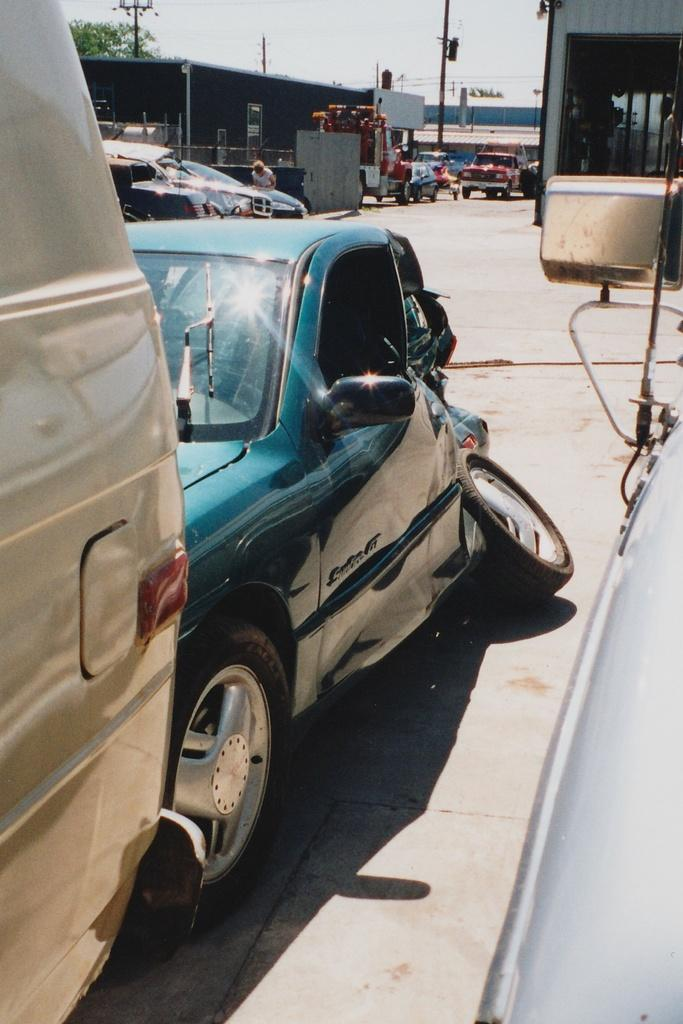What can be seen moving on the road in the image? There are vehicles visible on the road in the image. What part of the natural environment is visible in the image? The sky is visible in the image. What structure can be seen in the image? There is a pole in the image. What type of man-made structure is present in the image? There is a building in the image. What type of vegetation is visible in the image? There are trees in the image. What type of flower is being used as a symbol of protest in the image? There is no flower or protest present in the image. How many steps are visible in the image? There are no steps visible in the image. 